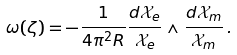Convert formula to latex. <formula><loc_0><loc_0><loc_500><loc_500>\omega ( \zeta ) = - \frac { 1 } { 4 \pi ^ { 2 } R } \frac { d \mathcal { X } _ { e } } { \mathcal { X } _ { e } } \wedge \frac { d \mathcal { X } _ { m } } { \mathcal { X } _ { m } } \, .</formula> 